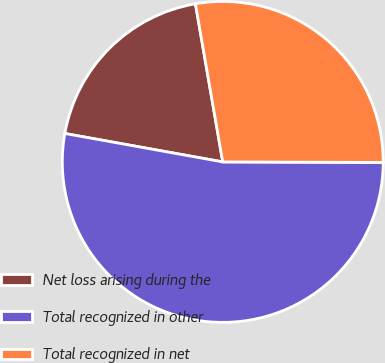Convert chart. <chart><loc_0><loc_0><loc_500><loc_500><pie_chart><fcel>Net loss arising during the<fcel>Total recognized in other<fcel>Total recognized in net<nl><fcel>19.44%<fcel>52.78%<fcel>27.78%<nl></chart> 